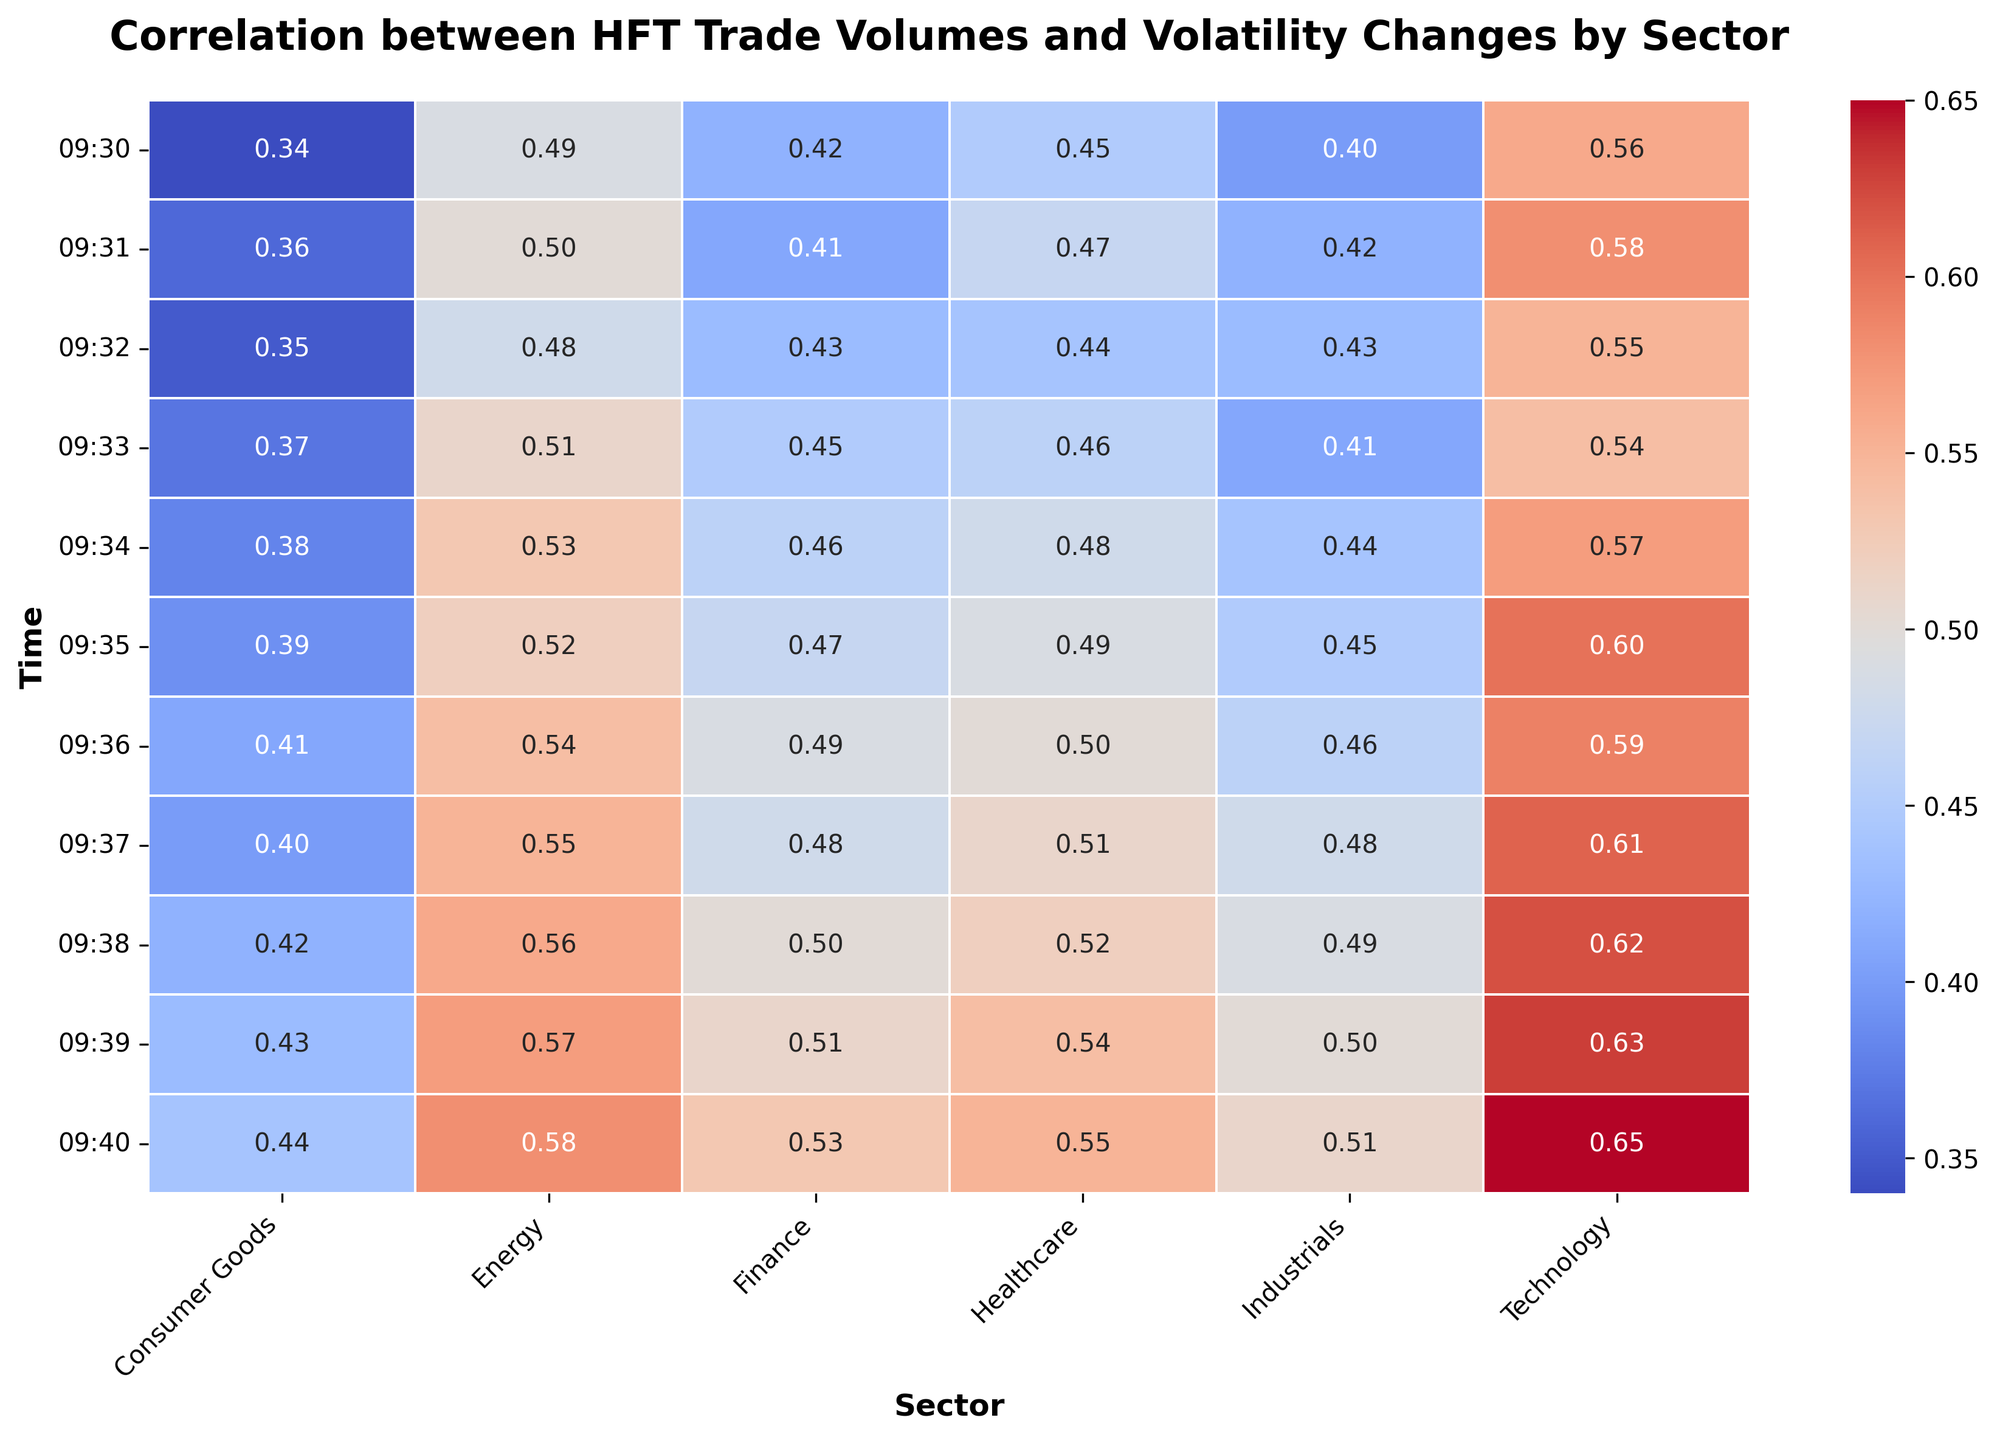Which sector shows the highest correlation at 09:40? To find this, look at the correlation values in the row corresponding to 09:40 and find the highest one. For 09:40, Technology has the highest value of 0.65.
Answer: Technology What is the difference in correlation between the Technology and Finance sectors at 09:32? Locate the correlation values for Technology and Finance at 09:32. Technology has a value of 0.55 and Finance has a value of 0.43. The difference is 0.55 - 0.43 = 0.12.
Answer: 0.12 Which sector has the lowest average correlation over the time period? Calculate the average correlation for each sector across all times. The sector with the smallest average is the one with the lowest average correlation. Consumer Goods has the lowest average. (Calculation steps: sum all Consumer Goods values and divide by their count).
Answer: Consumer Goods At what time does the Healthcare sector reach a correlation of 0.50 or higher for the first time? Review the correlations for Healthcare across all times and find the first instance where it is 0.50 or higher. It reaches 0.50 at 09:36.
Answer: 09:36 Compare the correlation trends between the Energy and Industrials sectors. Which sector shows a steeper initial increase? Look at the first few time points for both Energy and Industrials and analyze the change in correlation. Energy goes from 0.49 to 0.52 (an increase of 0.03) between 09:30 and 09:35, while Industrials change from 0.40 to 0.45 (an increase of 0.05) in the same period. Industrials show a steeper initial increase.
Answer: Industrials What is the visual pattern observed in the Technology sector over time? Observe the heatmap colors for the Technology sector over the time period from 09:30 to 09:40. Technology shows a steady increase in correlation, visually represented by a gradual shift from lighter to darker shades of red.
Answer: Steady Increase What is the sum of the correlations for the Energy sector at 09:32 and 09:33? Find the correlation values for Energy at 09:32 and 09:33. They are 0.48 and 0.51 respectively. Sum these values: 0.48 + 0.51 = 0.99.
Answer: 0.99 Are there any sectors with a decreasing trend in correlation over the observed time period? Examine the correlation values for each sector over time to see if any sectors show a decreasing trend. None of the sectors demonstrate an overall decreasing trend; most are either steady or increasing.
Answer: No 